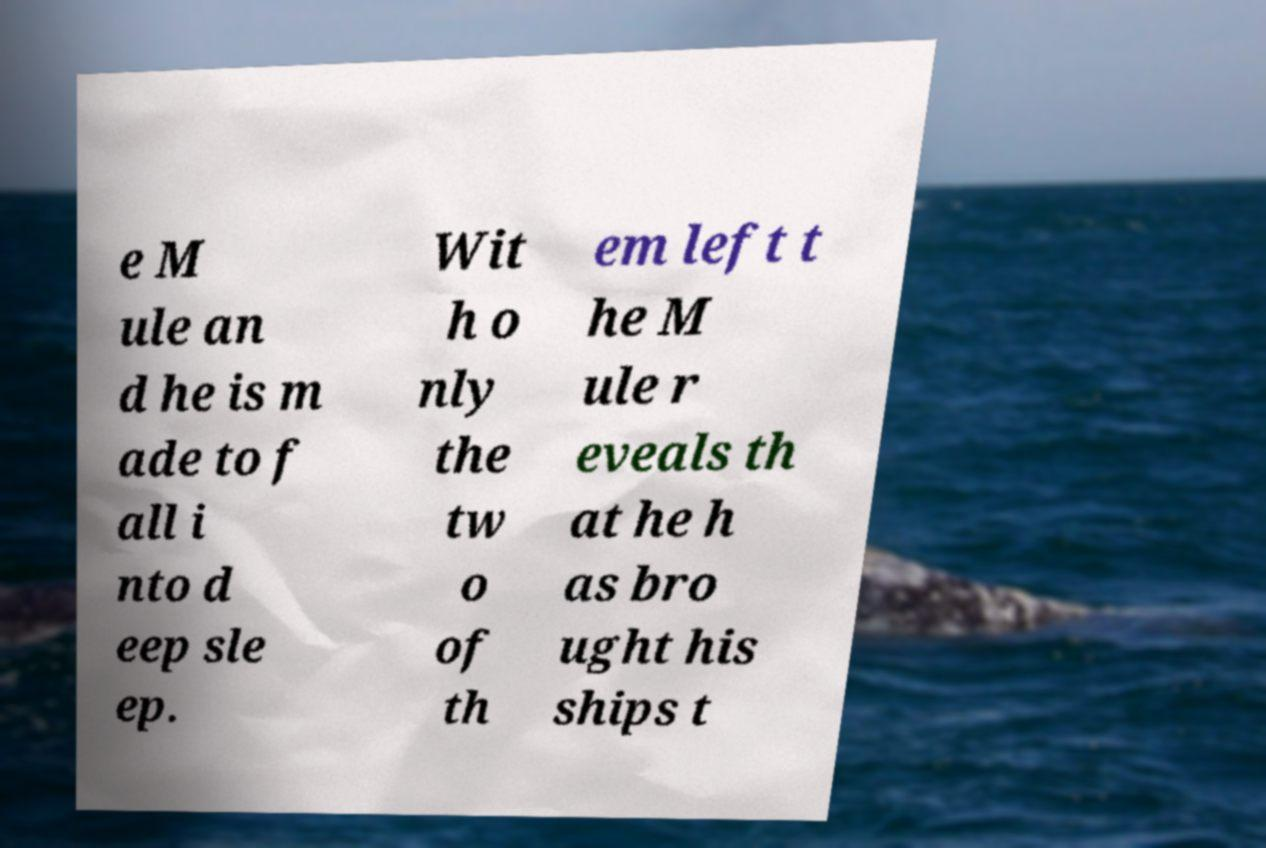I need the written content from this picture converted into text. Can you do that? e M ule an d he is m ade to f all i nto d eep sle ep. Wit h o nly the tw o of th em left t he M ule r eveals th at he h as bro ught his ships t 